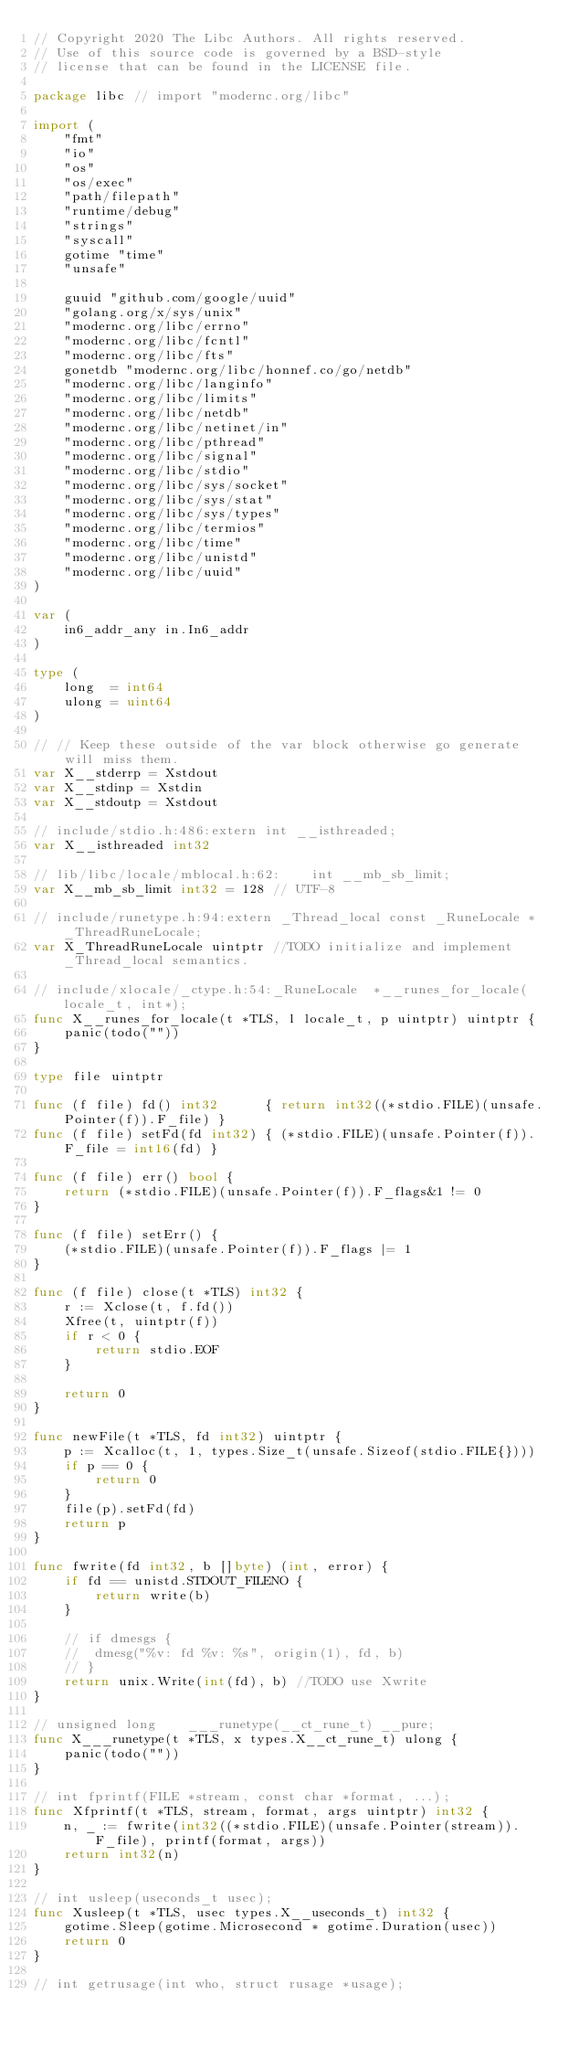<code> <loc_0><loc_0><loc_500><loc_500><_Go_>// Copyright 2020 The Libc Authors. All rights reserved.
// Use of this source code is governed by a BSD-style
// license that can be found in the LICENSE file.

package libc // import "modernc.org/libc"

import (
	"fmt"
	"io"
	"os"
	"os/exec"
	"path/filepath"
	"runtime/debug"
	"strings"
	"syscall"
	gotime "time"
	"unsafe"

	guuid "github.com/google/uuid"
	"golang.org/x/sys/unix"
	"modernc.org/libc/errno"
	"modernc.org/libc/fcntl"
	"modernc.org/libc/fts"
	gonetdb "modernc.org/libc/honnef.co/go/netdb"
	"modernc.org/libc/langinfo"
	"modernc.org/libc/limits"
	"modernc.org/libc/netdb"
	"modernc.org/libc/netinet/in"
	"modernc.org/libc/pthread"
	"modernc.org/libc/signal"
	"modernc.org/libc/stdio"
	"modernc.org/libc/sys/socket"
	"modernc.org/libc/sys/stat"
	"modernc.org/libc/sys/types"
	"modernc.org/libc/termios"
	"modernc.org/libc/time"
	"modernc.org/libc/unistd"
	"modernc.org/libc/uuid"
)

var (
	in6_addr_any in.In6_addr
)

type (
	long  = int64
	ulong = uint64
)

// // Keep these outside of the var block otherwise go generate will miss them.
var X__stderrp = Xstdout
var X__stdinp = Xstdin
var X__stdoutp = Xstdout

// include/stdio.h:486:extern int __isthreaded;
var X__isthreaded int32

// lib/libc/locale/mblocal.h:62:	int __mb_sb_limit;
var X__mb_sb_limit int32 = 128 // UTF-8

// include/runetype.h:94:extern _Thread_local const _RuneLocale *_ThreadRuneLocale;
var X_ThreadRuneLocale uintptr //TODO initialize and implement _Thread_local semantics.

// include/xlocale/_ctype.h:54:_RuneLocale	*__runes_for_locale(locale_t, int*);
func X__runes_for_locale(t *TLS, l locale_t, p uintptr) uintptr {
	panic(todo(""))
}

type file uintptr

func (f file) fd() int32      { return int32((*stdio.FILE)(unsafe.Pointer(f)).F_file) }
func (f file) setFd(fd int32) { (*stdio.FILE)(unsafe.Pointer(f)).F_file = int16(fd) }

func (f file) err() bool {
	return (*stdio.FILE)(unsafe.Pointer(f)).F_flags&1 != 0
}

func (f file) setErr() {
	(*stdio.FILE)(unsafe.Pointer(f)).F_flags |= 1
}

func (f file) close(t *TLS) int32 {
	r := Xclose(t, f.fd())
	Xfree(t, uintptr(f))
	if r < 0 {
		return stdio.EOF
	}

	return 0
}

func newFile(t *TLS, fd int32) uintptr {
	p := Xcalloc(t, 1, types.Size_t(unsafe.Sizeof(stdio.FILE{})))
	if p == 0 {
		return 0
	}
	file(p).setFd(fd)
	return p
}

func fwrite(fd int32, b []byte) (int, error) {
	if fd == unistd.STDOUT_FILENO {
		return write(b)
	}

	// if dmesgs {
	// 	dmesg("%v: fd %v: %s", origin(1), fd, b)
	// }
	return unix.Write(int(fd), b) //TODO use Xwrite
}

// unsigned long	___runetype(__ct_rune_t) __pure;
func X___runetype(t *TLS, x types.X__ct_rune_t) ulong {
	panic(todo(""))
}

// int fprintf(FILE *stream, const char *format, ...);
func Xfprintf(t *TLS, stream, format, args uintptr) int32 {
	n, _ := fwrite(int32((*stdio.FILE)(unsafe.Pointer(stream)).F_file), printf(format, args))
	return int32(n)
}

// int usleep(useconds_t usec);
func Xusleep(t *TLS, usec types.X__useconds_t) int32 {
	gotime.Sleep(gotime.Microsecond * gotime.Duration(usec))
	return 0
}

// int getrusage(int who, struct rusage *usage);</code> 